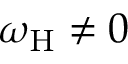<formula> <loc_0><loc_0><loc_500><loc_500>\omega _ { H } \neq 0</formula> 